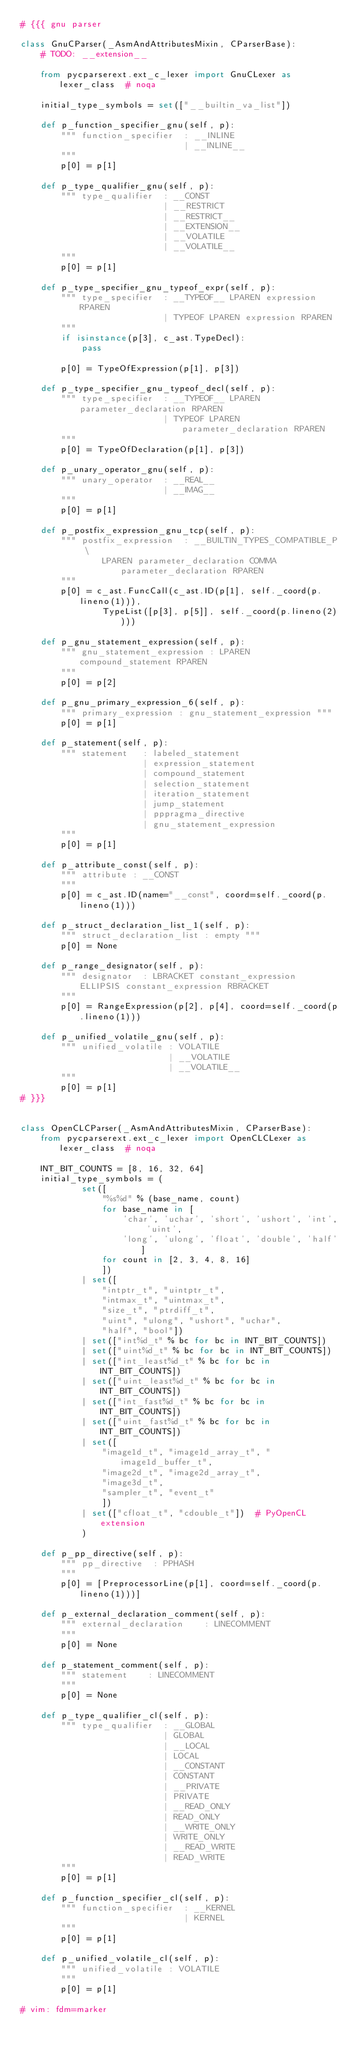Convert code to text. <code><loc_0><loc_0><loc_500><loc_500><_Python_># {{{ gnu parser

class GnuCParser(_AsmAndAttributesMixin, CParserBase):
    # TODO: __extension__

    from pycparserext.ext_c_lexer import GnuCLexer as lexer_class  # noqa

    initial_type_symbols = set(["__builtin_va_list"])

    def p_function_specifier_gnu(self, p):
        """ function_specifier  : __INLINE
                                | __INLINE__
        """
        p[0] = p[1]

    def p_type_qualifier_gnu(self, p):
        """ type_qualifier  : __CONST
                            | __RESTRICT
                            | __RESTRICT__
                            | __EXTENSION__
                            | __VOLATILE
                            | __VOLATILE__
        """
        p[0] = p[1]

    def p_type_specifier_gnu_typeof_expr(self, p):
        """ type_specifier  : __TYPEOF__ LPAREN expression RPAREN
                            | TYPEOF LPAREN expression RPAREN
        """
        if isinstance(p[3], c_ast.TypeDecl):
            pass

        p[0] = TypeOfExpression(p[1], p[3])

    def p_type_specifier_gnu_typeof_decl(self, p):
        """ type_specifier  : __TYPEOF__ LPAREN parameter_declaration RPAREN
                            | TYPEOF LPAREN parameter_declaration RPAREN
        """
        p[0] = TypeOfDeclaration(p[1], p[3])

    def p_unary_operator_gnu(self, p):
        """ unary_operator  : __REAL__
                            | __IMAG__
        """
        p[0] = p[1]

    def p_postfix_expression_gnu_tcp(self, p):
        """ postfix_expression  : __BUILTIN_TYPES_COMPATIBLE_P \
                LPAREN parameter_declaration COMMA parameter_declaration RPAREN
        """
        p[0] = c_ast.FuncCall(c_ast.ID(p[1], self._coord(p.lineno(1))),
                TypeList([p[3], p[5]], self._coord(p.lineno(2))))

    def p_gnu_statement_expression(self, p):
        """ gnu_statement_expression : LPAREN compound_statement RPAREN
        """
        p[0] = p[2]

    def p_gnu_primary_expression_6(self, p):
        """ primary_expression : gnu_statement_expression """
        p[0] = p[1]

    def p_statement(self, p):
        """ statement   : labeled_statement
                        | expression_statement
                        | compound_statement
                        | selection_statement
                        | iteration_statement
                        | jump_statement
                        | pppragma_directive
                        | gnu_statement_expression
        """
        p[0] = p[1]

    def p_attribute_const(self, p):
        """ attribute : __CONST
        """
        p[0] = c_ast.ID(name="__const", coord=self._coord(p.lineno(1)))

    def p_struct_declaration_list_1(self, p):
        """ struct_declaration_list : empty """
        p[0] = None

    def p_range_designator(self, p):
        """ designator  : LBRACKET constant_expression ELLIPSIS constant_expression RBRACKET
        """
        p[0] = RangeExpression(p[2], p[4], coord=self._coord(p.lineno(1)))

    def p_unified_volatile_gnu(self, p):
        """ unified_volatile : VOLATILE
                             | __VOLATILE
                             | __VOLATILE__
        """
        p[0] = p[1]
# }}}


class OpenCLCParser(_AsmAndAttributesMixin, CParserBase):
    from pycparserext.ext_c_lexer import OpenCLCLexer as lexer_class  # noqa

    INT_BIT_COUNTS = [8, 16, 32, 64]
    initial_type_symbols = (
            set([
                "%s%d" % (base_name, count)
                for base_name in [
                    'char', 'uchar', 'short', 'ushort', 'int', 'uint',
                    'long', 'ulong', 'float', 'double', 'half']
                for count in [2, 3, 4, 8, 16]
                ])
            | set([
                "intptr_t", "uintptr_t",
                "intmax_t", "uintmax_t",
                "size_t", "ptrdiff_t",
                "uint", "ulong", "ushort", "uchar",
                "half", "bool"])
            | set(["int%d_t" % bc for bc in INT_BIT_COUNTS])
            | set(["uint%d_t" % bc for bc in INT_BIT_COUNTS])
            | set(["int_least%d_t" % bc for bc in INT_BIT_COUNTS])
            | set(["uint_least%d_t" % bc for bc in INT_BIT_COUNTS])
            | set(["int_fast%d_t" % bc for bc in INT_BIT_COUNTS])
            | set(["uint_fast%d_t" % bc for bc in INT_BIT_COUNTS])
            | set([
                "image1d_t", "image1d_array_t", "image1d_buffer_t",
                "image2d_t", "image2d_array_t",
                "image3d_t",
                "sampler_t", "event_t"
                ])
            | set(["cfloat_t", "cdouble_t"])  # PyOpenCL extension
            )

    def p_pp_directive(self, p):
        """ pp_directive  : PPHASH
        """
        p[0] = [PreprocessorLine(p[1], coord=self._coord(p.lineno(1)))]

    def p_external_declaration_comment(self, p):
        """ external_declaration    : LINECOMMENT
        """
        p[0] = None

    def p_statement_comment(self, p):
        """ statement    : LINECOMMENT
        """
        p[0] = None

    def p_type_qualifier_cl(self, p):
        """ type_qualifier  : __GLOBAL
                            | GLOBAL
                            | __LOCAL
                            | LOCAL
                            | __CONSTANT
                            | CONSTANT
                            | __PRIVATE
                            | PRIVATE
                            | __READ_ONLY
                            | READ_ONLY
                            | __WRITE_ONLY
                            | WRITE_ONLY
                            | __READ_WRITE
                            | READ_WRITE
        """
        p[0] = p[1]

    def p_function_specifier_cl(self, p):
        """ function_specifier  : __KERNEL
                                | KERNEL
        """
        p[0] = p[1]

    def p_unified_volatile_cl(self, p):
        """ unified_volatile : VOLATILE
        """
        p[0] = p[1]

# vim: fdm=marker
</code> 